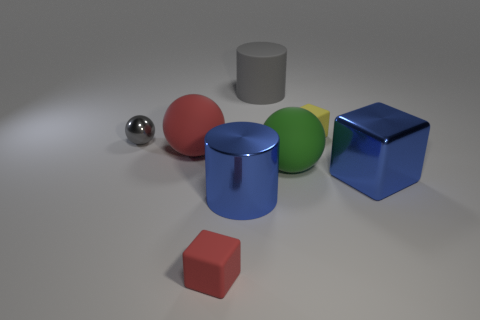There is a shiny thing that is the same color as the large cube; what size is it?
Offer a very short reply. Large. Does the tiny matte cube that is in front of the shiny cube have the same color as the large cube?
Keep it short and to the point. No. There is a large object that is the same color as the big block; what material is it?
Make the answer very short. Metal. Are there any metal cylinders that have the same color as the shiny block?
Your answer should be compact. Yes. What material is the small cube behind the big metallic thing right of the big gray rubber thing made of?
Your answer should be compact. Rubber. What is the block that is on the right side of the tiny red matte object and in front of the yellow cube made of?
Offer a very short reply. Metal. Are there an equal number of blue metal cubes on the left side of the red matte cube and large red matte spheres?
Offer a very short reply. No. How many small red matte objects have the same shape as the gray matte thing?
Provide a succinct answer. 0. What is the size of the matte cube in front of the gray thing that is left of the blue cylinder that is on the left side of the large green ball?
Offer a terse response. Small. Is the blue thing on the right side of the green rubber ball made of the same material as the large gray cylinder?
Give a very brief answer. No. 